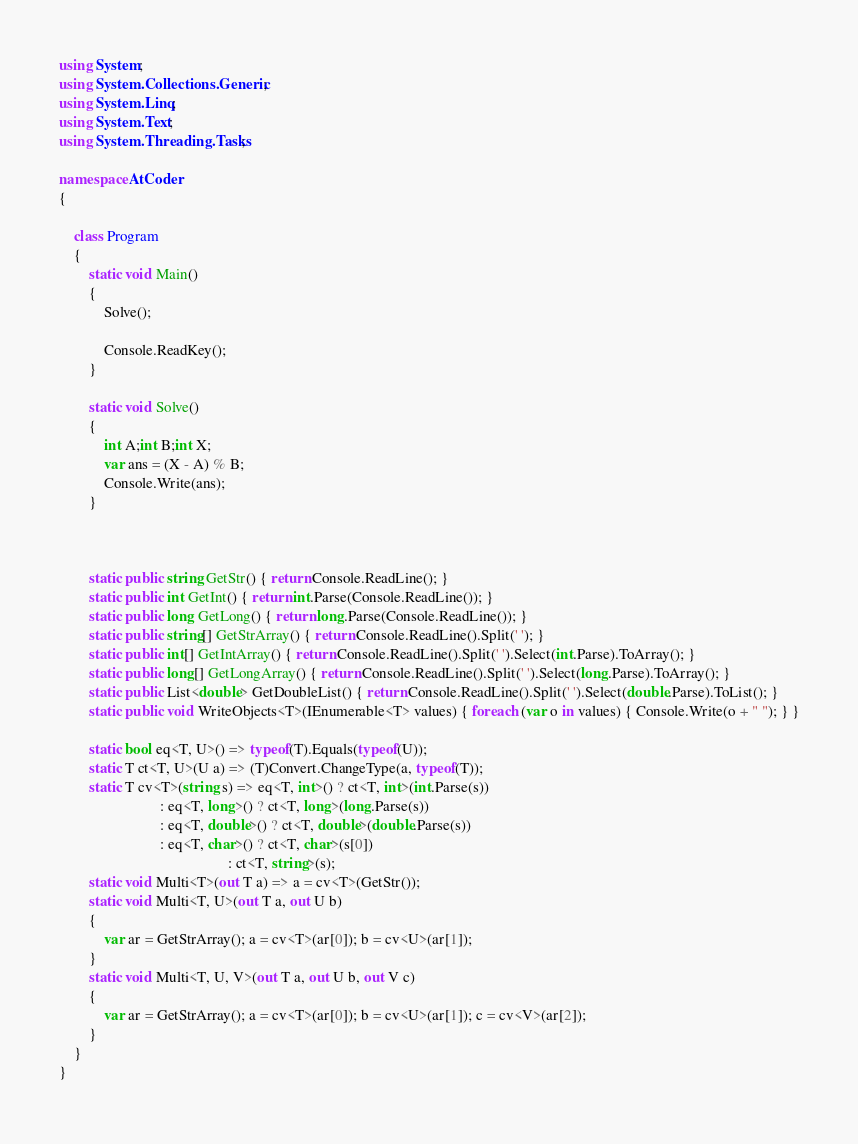Convert code to text. <code><loc_0><loc_0><loc_500><loc_500><_C#_>using System;
using System.Collections.Generic;
using System.Linq;
using System.Text;
using System.Threading.Tasks;

namespace AtCoder
{

    class Program
    {
        static void Main()
        {
            Solve();

            Console.ReadKey();
        }

        static void Solve()
        {
            int A;int B;int X;
            var ans = (X - A) % B;
            Console.Write(ans);
        }



        static public string GetStr() { return Console.ReadLine(); }
        static public int GetInt() { return int.Parse(Console.ReadLine()); }
        static public long GetLong() { return long.Parse(Console.ReadLine()); }
        static public string[] GetStrArray() { return Console.ReadLine().Split(' '); }
        static public int[] GetIntArray() { return Console.ReadLine().Split(' ').Select(int.Parse).ToArray(); }
        static public long[] GetLongArray() { return Console.ReadLine().Split(' ').Select(long.Parse).ToArray(); }
        static public List<double> GetDoubleList() { return Console.ReadLine().Split(' ').Select(double.Parse).ToList(); }
        static public void WriteObjects<T>(IEnumerable<T> values) { foreach (var o in values) { Console.Write(o + " "); } }

        static bool eq<T, U>() => typeof(T).Equals(typeof(U));
        static T ct<T, U>(U a) => (T)Convert.ChangeType(a, typeof(T));
        static T cv<T>(string s) => eq<T, int>() ? ct<T, int>(int.Parse(s))
                           : eq<T, long>() ? ct<T, long>(long.Parse(s))
                           : eq<T, double>() ? ct<T, double>(double.Parse(s))
                           : eq<T, char>() ? ct<T, char>(s[0])
                                             : ct<T, string>(s);
        static void Multi<T>(out T a) => a = cv<T>(GetStr());
        static void Multi<T, U>(out T a, out U b)
        {
            var ar = GetStrArray(); a = cv<T>(ar[0]); b = cv<U>(ar[1]);
        }
        static void Multi<T, U, V>(out T a, out U b, out V c)
        {
            var ar = GetStrArray(); a = cv<T>(ar[0]); b = cv<U>(ar[1]); c = cv<V>(ar[2]);
        }
    }
}</code> 